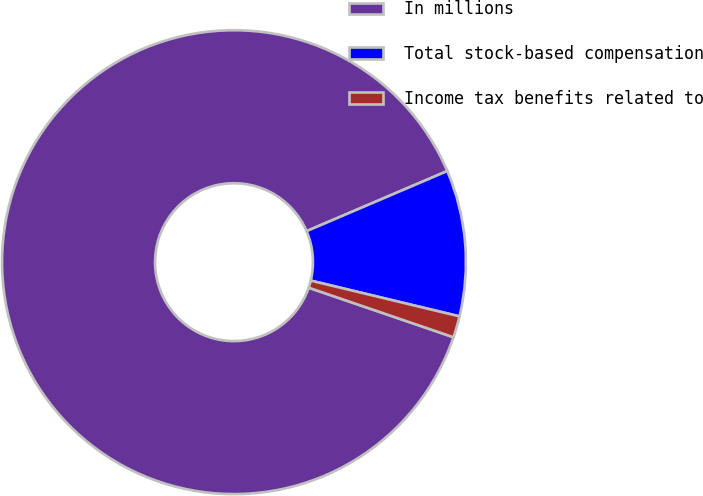<chart> <loc_0><loc_0><loc_500><loc_500><pie_chart><fcel>In millions<fcel>Total stock-based compensation<fcel>Income tax benefits related to<nl><fcel>88.33%<fcel>10.18%<fcel>1.49%<nl></chart> 